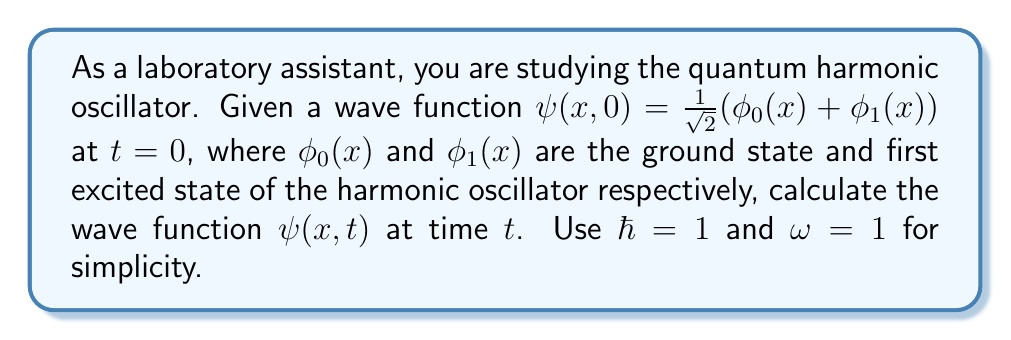What is the answer to this math problem? 1) First, recall that the time-dependent Schrödinger equation for a harmonic oscillator is:

   $$i\hbar\frac{\partial}{\partial t}\psi(x,t) = \hat{H}\psi(x,t)$$

   where $\hat{H}$ is the Hamiltonian operator.

2) The general solution for the time-dependent wave function is:

   $$\psi(x,t) = \sum_n c_n\phi_n(x)e^{-iE_nt/\hbar}$$

   where $c_n$ are complex coefficients, $\phi_n(x)$ are the stationary states, and $E_n$ are the energy levels.

3) For a harmonic oscillator, the energy levels are given by:

   $$E_n = \hbar\omega(n + \frac{1}{2})$$

4) In our case, we have:
   
   $$\psi(x,0) = \frac{1}{\sqrt{2}}(\phi_0(x) + \phi_1(x))$$

   So, $c_0 = c_1 = \frac{1}{\sqrt{2}}$, and all other $c_n = 0$.

5) Substituting into the general solution:

   $$\psi(x,t) = \frac{1}{\sqrt{2}}\phi_0(x)e^{-iE_0t/\hbar} + \frac{1}{\sqrt{2}}\phi_1(x)e^{-iE_1t/\hbar}$$

6) Using $\hbar = 1$ and $\omega = 1$:

   $$E_0 = \frac{1}{2}, E_1 = \frac{3}{2}$$

7) Therefore, the final solution is:

   $$\psi(x,t) = \frac{1}{\sqrt{2}}\phi_0(x)e^{-it/2} + \frac{1}{\sqrt{2}}\phi_1(x)e^{-3it/2}$$
Answer: $\psi(x,t) = \frac{1}{\sqrt{2}}\phi_0(x)e^{-it/2} + \frac{1}{\sqrt{2}}\phi_1(x)e^{-3it/2}$ 